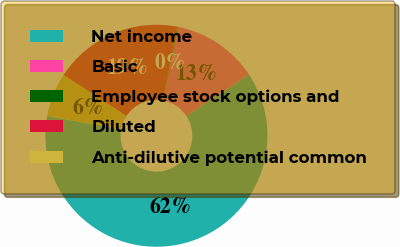Convert chart to OTSL. <chart><loc_0><loc_0><loc_500><loc_500><pie_chart><fcel>Net income<fcel>Basic<fcel>Employee stock options and<fcel>Diluted<fcel>Anti-dilutive potential common<nl><fcel>62.17%<fcel>12.56%<fcel>0.15%<fcel>18.76%<fcel>6.36%<nl></chart> 